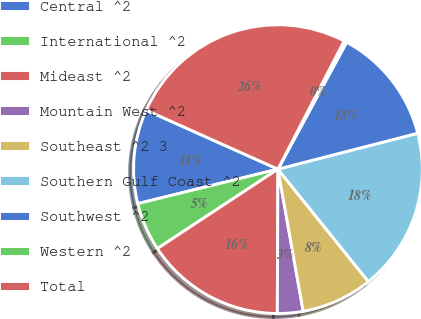Convert chart. <chart><loc_0><loc_0><loc_500><loc_500><pie_chart><fcel>Central ^2<fcel>International ^2<fcel>Mideast ^2<fcel>Mountain West ^2<fcel>Southeast ^2 3<fcel>Southern Gulf Coast ^2<fcel>Southwest ^2<fcel>Western ^2<fcel>Total<nl><fcel>10.54%<fcel>5.43%<fcel>15.66%<fcel>2.87%<fcel>7.98%<fcel>18.22%<fcel>13.1%<fcel>0.31%<fcel>25.89%<nl></chart> 